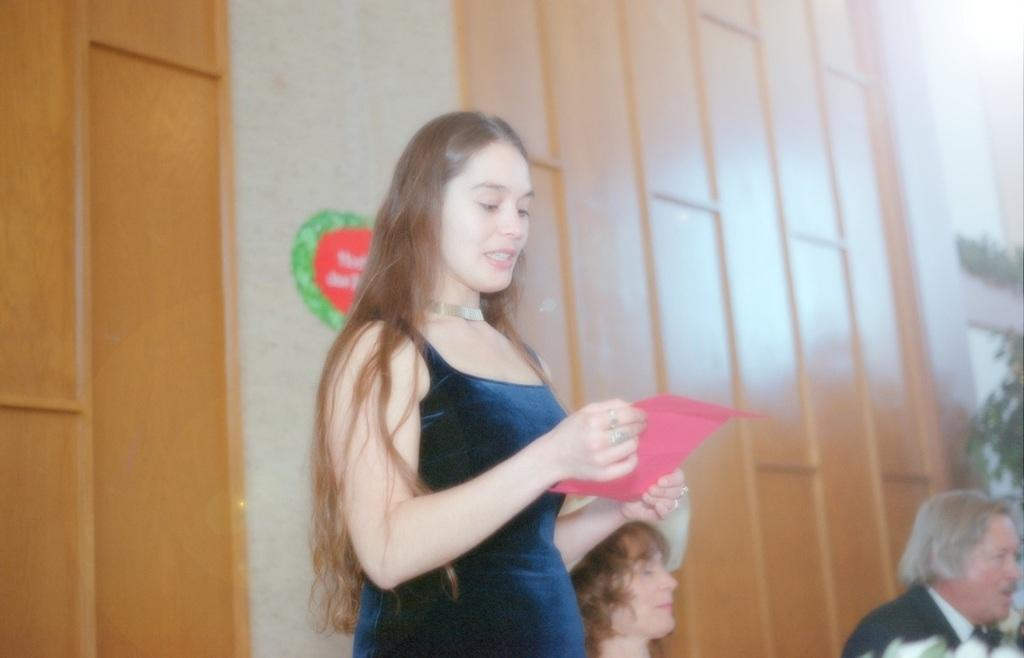What is the person in the image holding? The person is holding a paper in the image. How many other people are present in the image? There are two other people in the image. What can be seen in the background of the image? There is a wall visible in the background of the image. What type of vegetation is present in the image? There is a plant on the right side of the image. What type of cable can be seen running along the sidewalk in the image? There is no sidewalk or cable present in the image. 